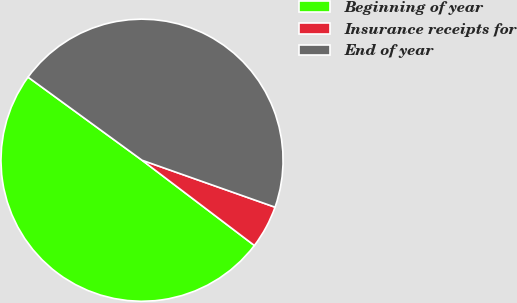Convert chart to OTSL. <chart><loc_0><loc_0><loc_500><loc_500><pie_chart><fcel>Beginning of year<fcel>Insurance receipts for<fcel>End of year<nl><fcel>49.7%<fcel>4.93%<fcel>45.38%<nl></chart> 